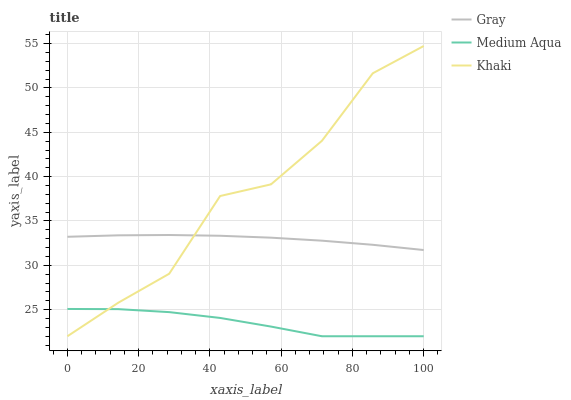Does Medium Aqua have the minimum area under the curve?
Answer yes or no. Yes. Does Khaki have the maximum area under the curve?
Answer yes or no. Yes. Does Khaki have the minimum area under the curve?
Answer yes or no. No. Does Medium Aqua have the maximum area under the curve?
Answer yes or no. No. Is Gray the smoothest?
Answer yes or no. Yes. Is Khaki the roughest?
Answer yes or no. Yes. Is Medium Aqua the smoothest?
Answer yes or no. No. Is Medium Aqua the roughest?
Answer yes or no. No. Does Khaki have the lowest value?
Answer yes or no. Yes. Does Khaki have the highest value?
Answer yes or no. Yes. Does Medium Aqua have the highest value?
Answer yes or no. No. Is Medium Aqua less than Gray?
Answer yes or no. Yes. Is Gray greater than Medium Aqua?
Answer yes or no. Yes. Does Khaki intersect Gray?
Answer yes or no. Yes. Is Khaki less than Gray?
Answer yes or no. No. Is Khaki greater than Gray?
Answer yes or no. No. Does Medium Aqua intersect Gray?
Answer yes or no. No. 